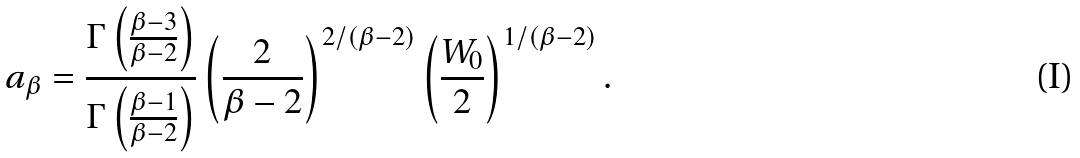<formula> <loc_0><loc_0><loc_500><loc_500>a _ { \beta } = \frac { \Gamma \left ( \frac { \beta - 3 } { \beta - 2 } \right ) } { \Gamma \left ( \frac { \beta - 1 } { \beta - 2 } \right ) } \left ( \frac { 2 } { \beta - 2 } \right ) ^ { 2 / ( \beta - 2 ) } \left ( \frac { W _ { 0 } } { 2 } \right ) ^ { 1 / ( \beta - 2 ) } .</formula> 